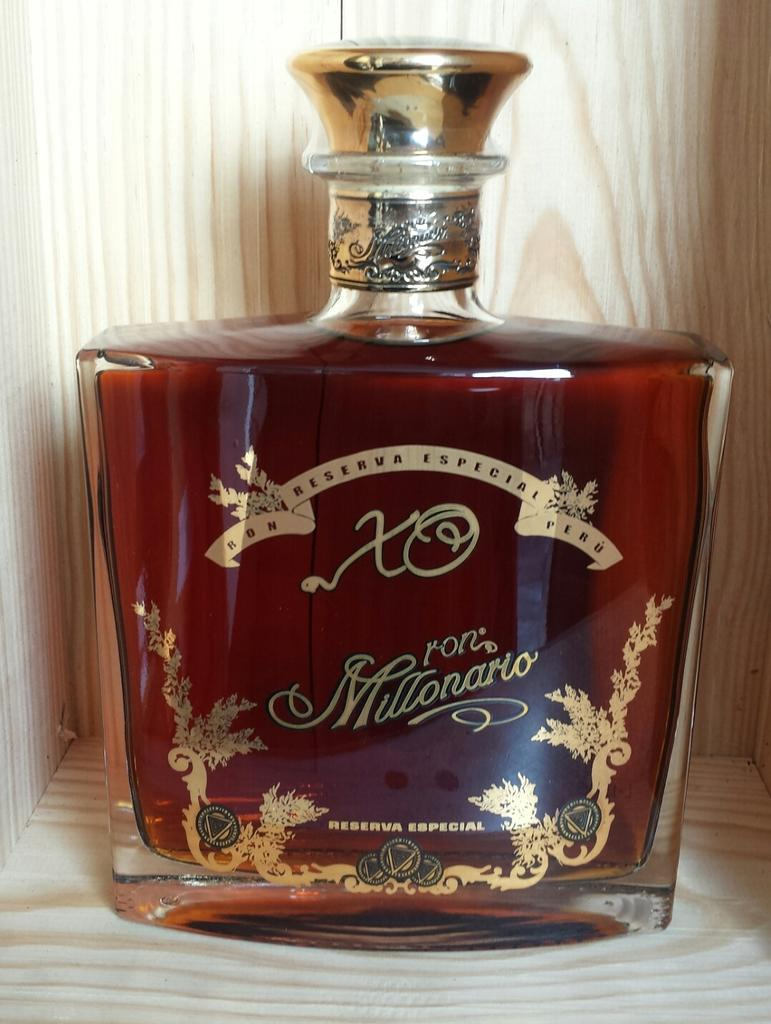<image>
Give a short and clear explanation of the subsequent image. A bottle that has the letters XO and the name Ron Millonario on it. 